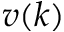<formula> <loc_0><loc_0><loc_500><loc_500>v ( k )</formula> 